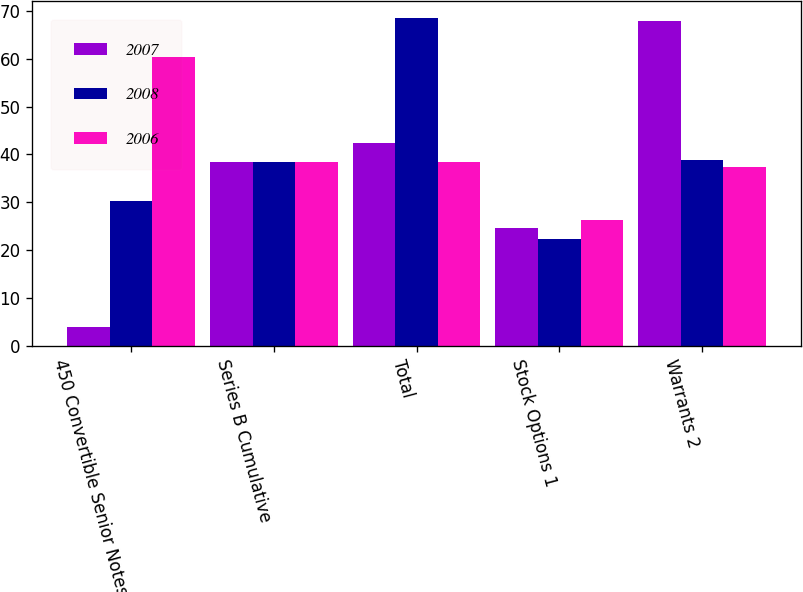Convert chart. <chart><loc_0><loc_0><loc_500><loc_500><stacked_bar_chart><ecel><fcel>450 Convertible Senior Notes<fcel>Series B Cumulative<fcel>Total<fcel>Stock Options 1<fcel>Warrants 2<nl><fcel>2007<fcel>3.9<fcel>38.4<fcel>42.3<fcel>24.7<fcel>67.9<nl><fcel>2008<fcel>30.2<fcel>38.4<fcel>68.6<fcel>22.4<fcel>38.8<nl><fcel>2006<fcel>60.3<fcel>38.4<fcel>38.4<fcel>26.3<fcel>37.4<nl></chart> 